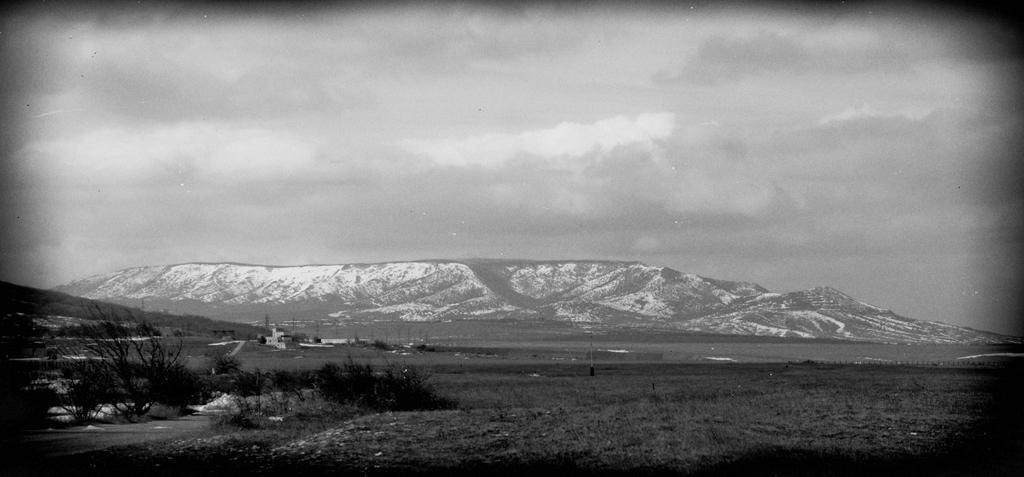Could you give a brief overview of what you see in this image? This is a black and white image, in this image there is a field, trees and hills, in the background there is a sky. 